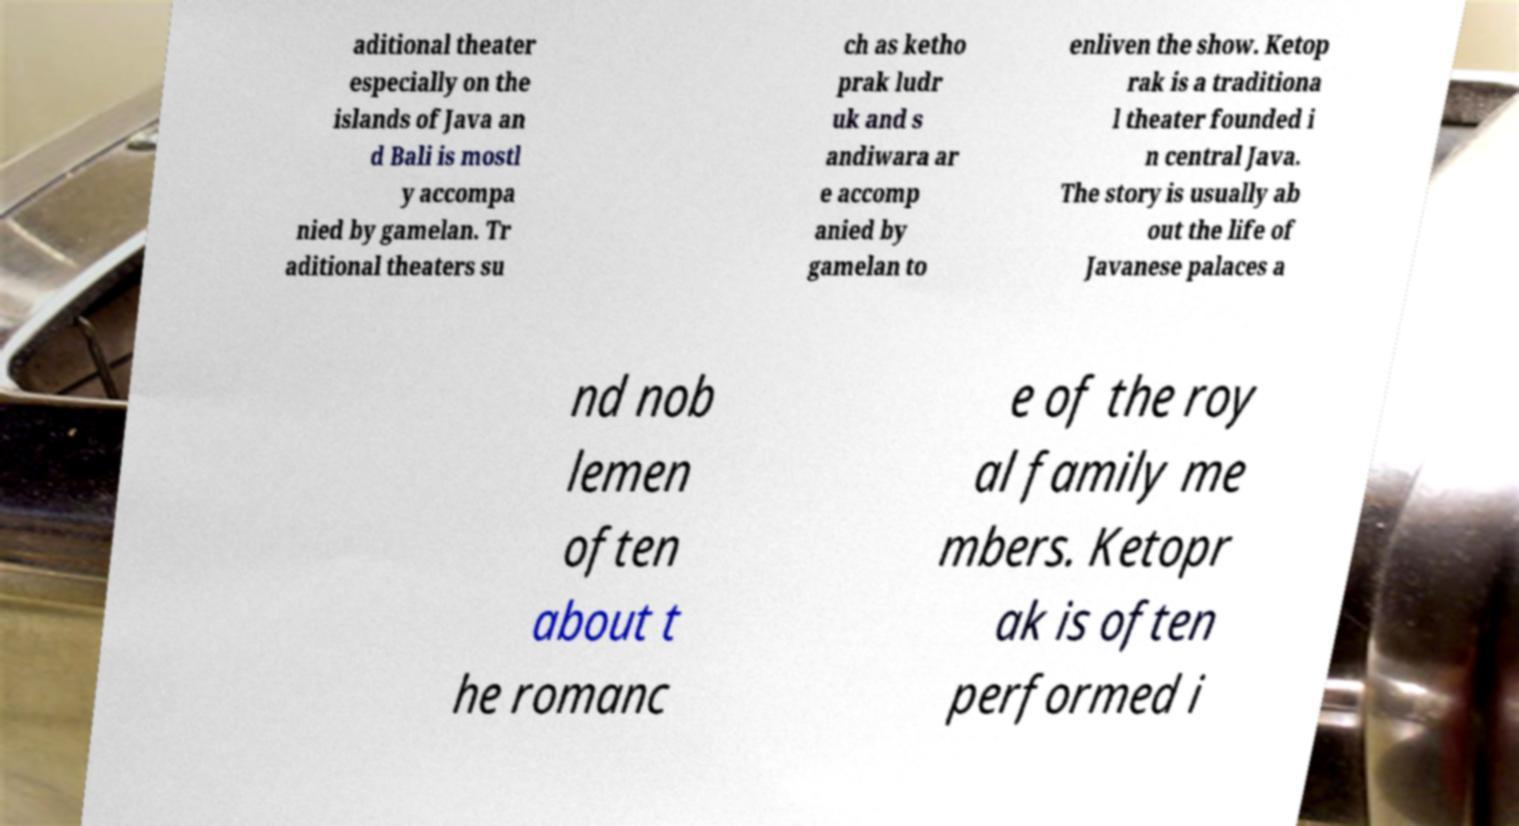Could you extract and type out the text from this image? aditional theater especially on the islands of Java an d Bali is mostl y accompa nied by gamelan. Tr aditional theaters su ch as ketho prak ludr uk and s andiwara ar e accomp anied by gamelan to enliven the show. Ketop rak is a traditiona l theater founded i n central Java. The story is usually ab out the life of Javanese palaces a nd nob lemen often about t he romanc e of the roy al family me mbers. Ketopr ak is often performed i 